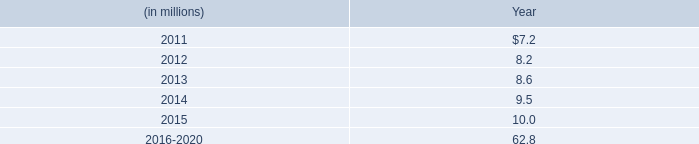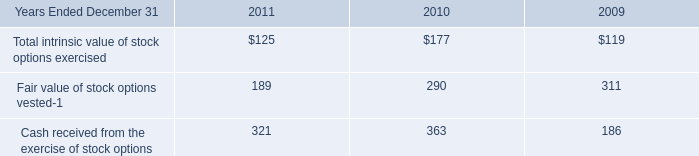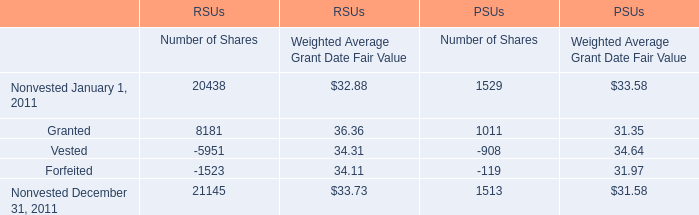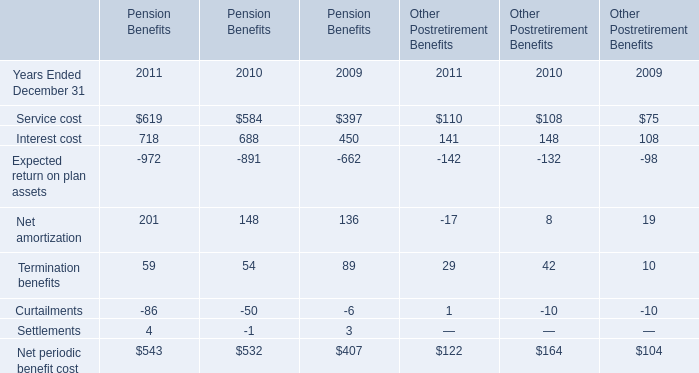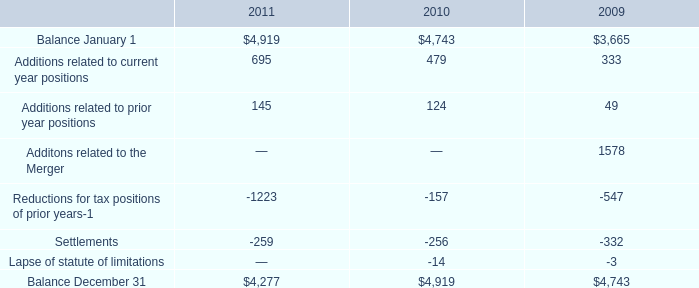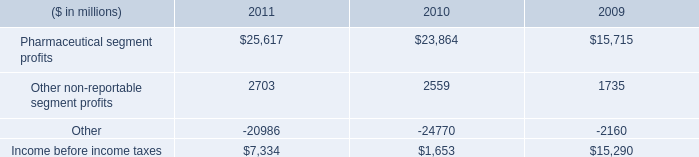What's the 80% of total elements for Pension Benefits in 2011? 
Computations: (543 * 0.8)
Answer: 434.4. 